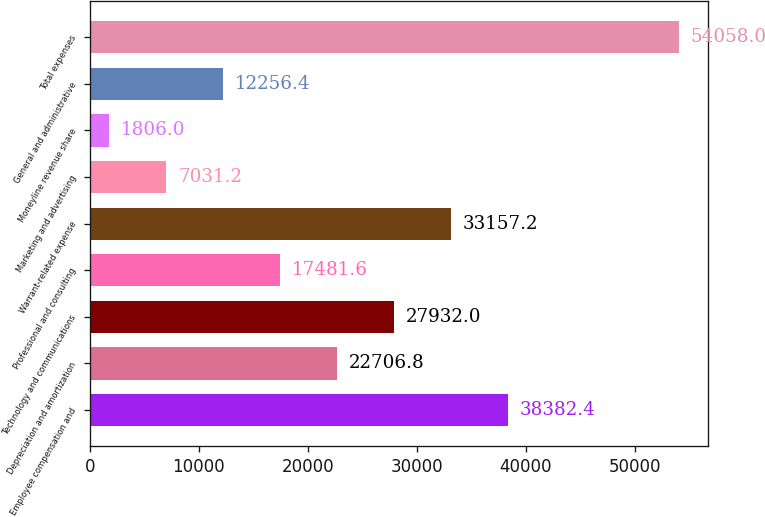Convert chart. <chart><loc_0><loc_0><loc_500><loc_500><bar_chart><fcel>Employee compensation and<fcel>Depreciation and amortization<fcel>Technology and communications<fcel>Professional and consulting<fcel>Warrant-related expense<fcel>Marketing and advertising<fcel>Moneyline revenue share<fcel>General and administrative<fcel>Total expenses<nl><fcel>38382.4<fcel>22706.8<fcel>27932<fcel>17481.6<fcel>33157.2<fcel>7031.2<fcel>1806<fcel>12256.4<fcel>54058<nl></chart> 